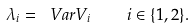<formula> <loc_0><loc_0><loc_500><loc_500>\lambda _ { i } = \ V a r { V _ { i } } \quad i \in \{ 1 , 2 \} .</formula> 